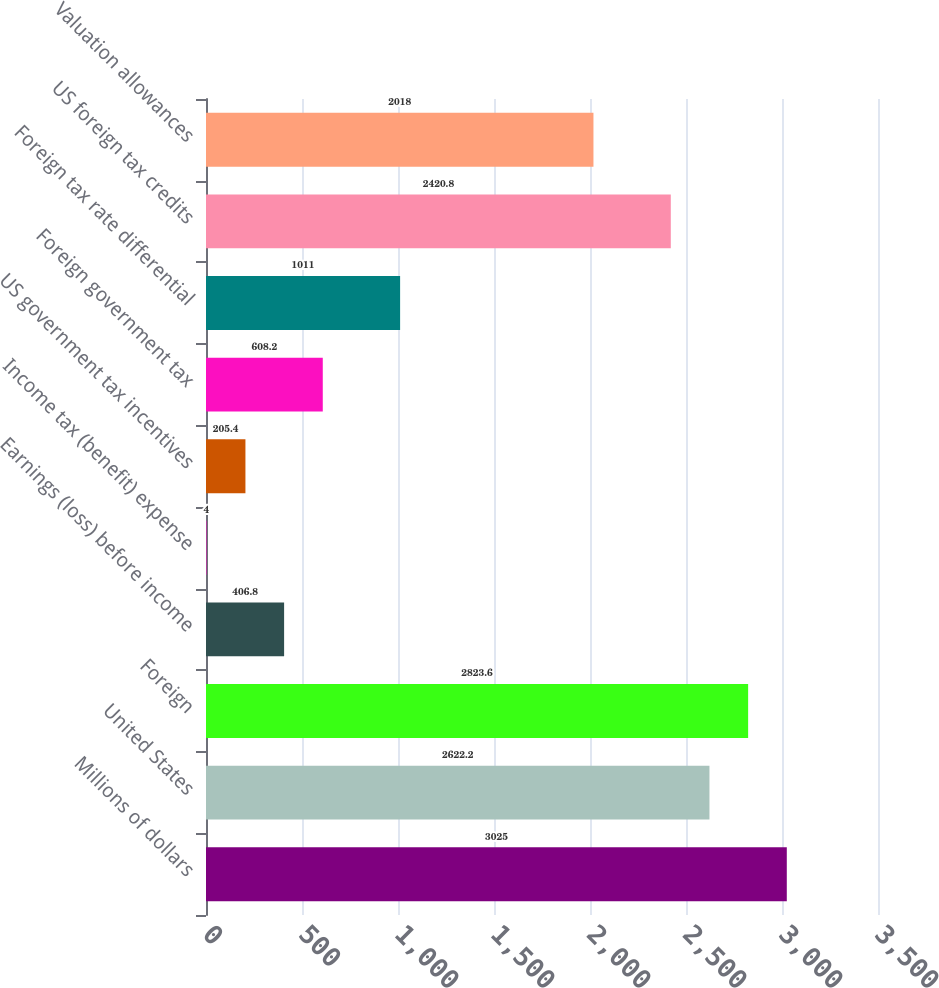Convert chart to OTSL. <chart><loc_0><loc_0><loc_500><loc_500><bar_chart><fcel>Millions of dollars<fcel>United States<fcel>Foreign<fcel>Earnings (loss) before income<fcel>Income tax (benefit) expense<fcel>US government tax incentives<fcel>Foreign government tax<fcel>Foreign tax rate differential<fcel>US foreign tax credits<fcel>Valuation allowances<nl><fcel>3025<fcel>2622.2<fcel>2823.6<fcel>406.8<fcel>4<fcel>205.4<fcel>608.2<fcel>1011<fcel>2420.8<fcel>2018<nl></chart> 